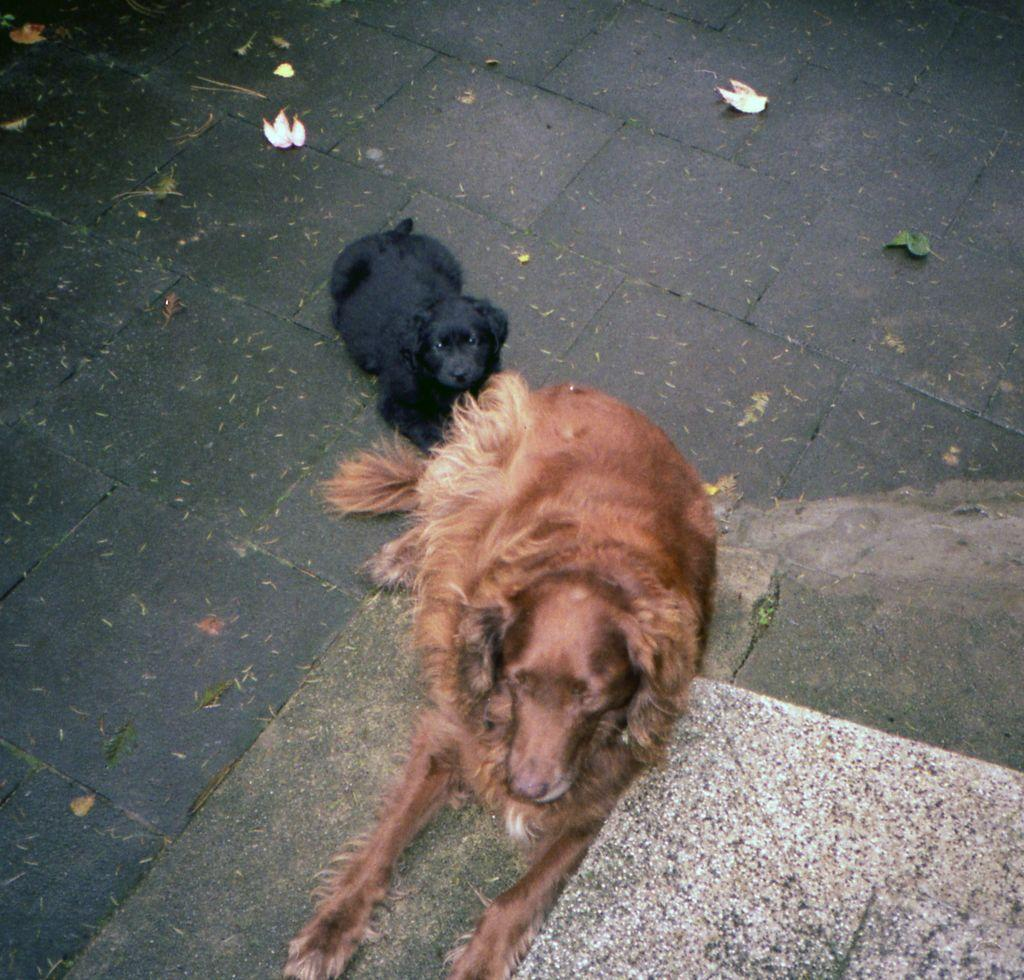What animals are in the center of the image? There are two dogs in the center of the image. What can be seen in the background of the image? There is a road visible in the background of the image. Where is the canvas located in the image? There is no canvas present in the image. Can you see any bears in the image? There are no bears visible in the image; it features two dogs. 